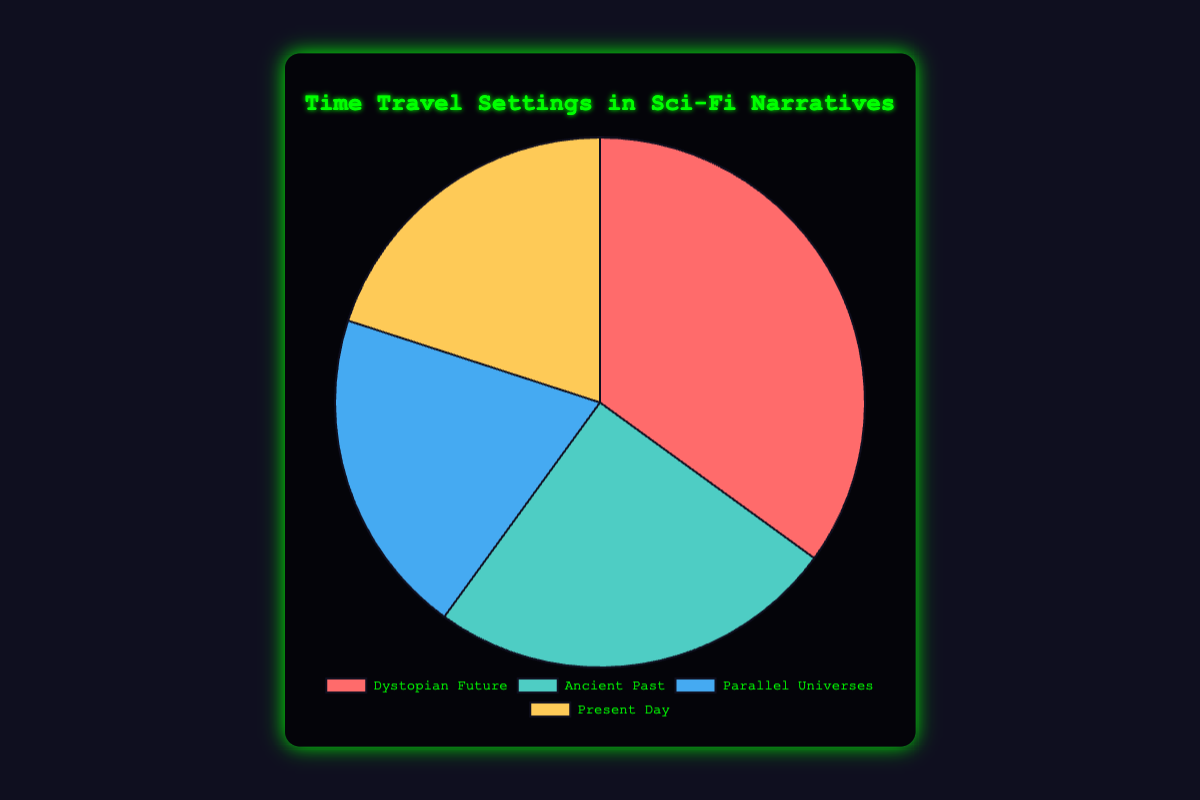What's the most frequently used setting in Sci-Fi Time Travel Narratives? The pie chart shows that "Dystopian Future" has the highest percentage of usage, marked by the largest slice. The data supports this: Dystopian Future has 35%, which is higher than the percentages for other settings.
Answer: Dystopian Future Which two settings have an equal percentage of usage? The pie chart data indicates that "Parallel Universes" and "Present Day" both account for 20% each. The slices representing these settings are identical in size.
Answer: Parallel Universes, Present Day What is the combined percentage for "Parallel Universes" and "Present Day"? According to the pie chart, "Parallel Universes" accounts for 20%, and "Present Day" also accounts for 20%. Adding these percentages gives 20% + 20% = 40%.
Answer: 40% Which setting has the second-highest usage percentage? The pie chart shows that "Ancient Past" has the second-largest slice. According to the data, "Ancient Past" has 25%, which is the second-highest after "Dystopian Future".
Answer: Ancient Past What's the difference in percentage between the most used and least used settings? The most used setting is "Dystopian Future" (35%), and the least used settings are "Parallel Universes" and "Present Day" (20% each). The difference is 35% - 20% = 15%.
Answer: 15% Which setting is represented by the blue slice? The visual attributes of the pie chart indicate that the blue slice represents "Parallel Universes", as it is depicted with a blue color.
Answer: Parallel Universes Is the usage of "Ancient Past" greater than "Parallel Universes"? According to the pie chart, "Ancient Past" accounts for 25%, whereas "Parallel Universes" accounts for 20%. Therefore, "Ancient Past" has a higher percentage.
Answer: Yes Arrange the settings in descending order based on their usage percentage. The data shows the following percentages: Dystopian Future (35%), Ancient Past (25%), Parallel Universes (20%), Present Day (20%). In descending order: Dystopian Future, Ancient Past, Parallel Universes, Present Day.
Answer: Dystopian Future, Ancient Past, Parallel Universes, Present Day What is the average percentage of usage for all settings? The total percentage across four settings is 35% (Dystopian Future) + 25% (Ancient Past) + 20% (Parallel Universes) + 20% (Present Day) = 100%. Since there are four settings, the average percentage is 100% / 4 = 25%.
Answer: 25% 